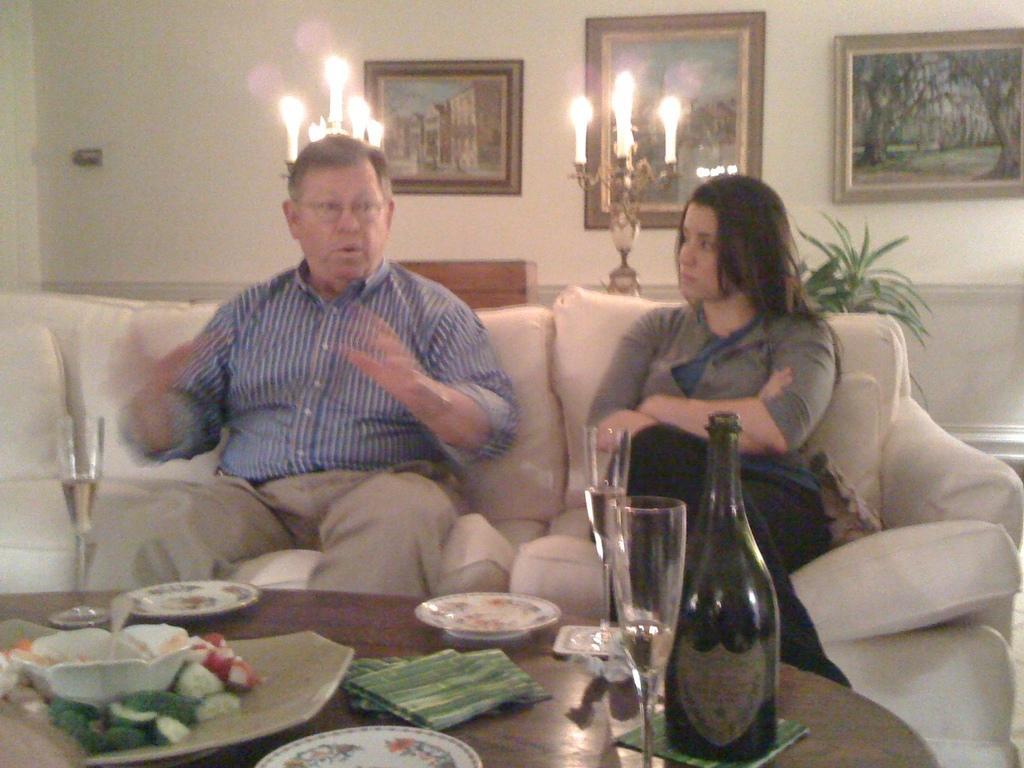Can you describe this image briefly? In this image i can see there are two persons sitting on the sofa set ,in front of them there is a table ,on the table there are some plates,glass,bottles and food items kept on the bowls visible and back ground of the person there is a wall, on the wall there are some photo frames attached to the wall And there are some lights visible back ground of them , and on the right side corner there is a planet visible. 